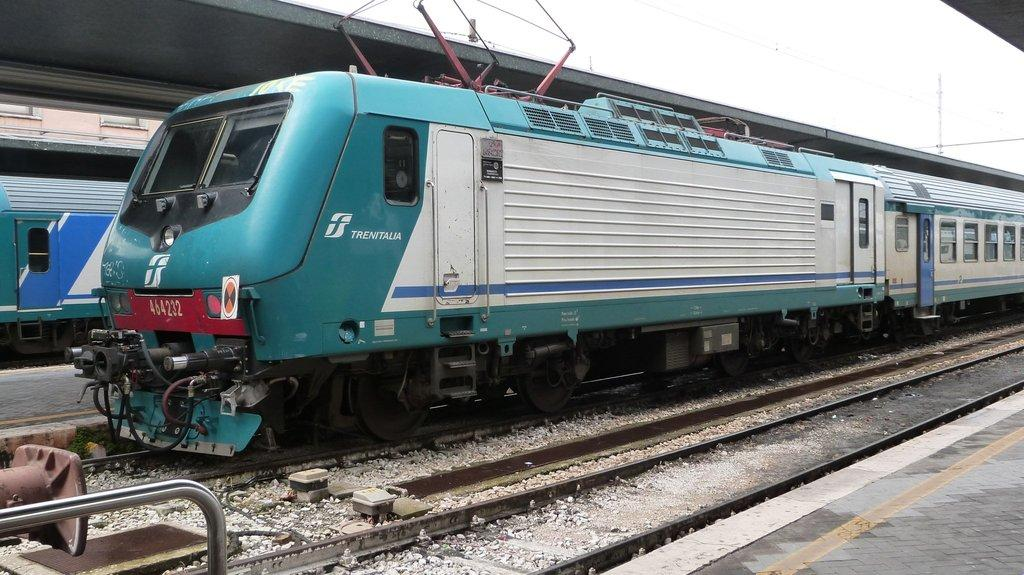<image>
Describe the image concisely. a train with the name of Trenitalia on the side. 